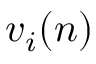Convert formula to latex. <formula><loc_0><loc_0><loc_500><loc_500>v _ { i } ( n )</formula> 